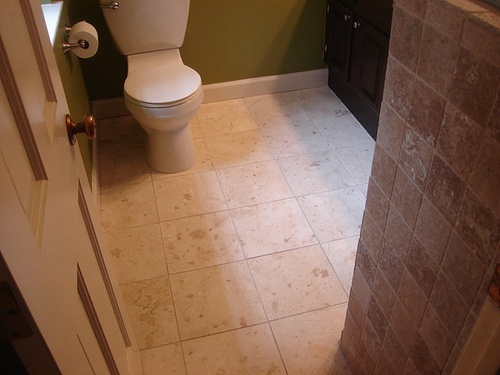Describe the objects in this image and their specific colors. I can see a toilet in brown, gray, maroon, and tan tones in this image. 